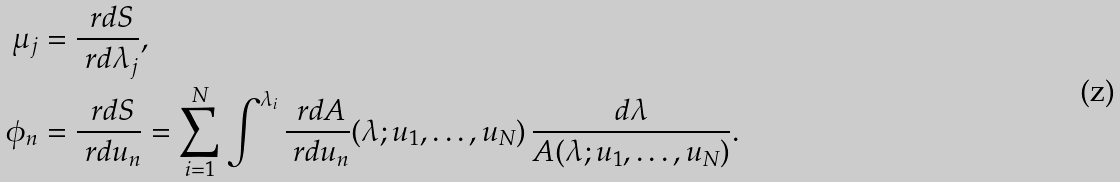Convert formula to latex. <formula><loc_0><loc_0><loc_500><loc_500>\mu _ { j } & = \frac { \ r d S } { \ r d \lambda _ { j } } , \\ \phi _ { n } & = \frac { \ r d S } { \ r d u _ { n } } = \sum _ { i = 1 } ^ { N } \int ^ { \lambda _ { i } } \frac { \ r d A } { \ r d u _ { n } } ( \lambda ; u _ { 1 } , \dots , u _ { N } ) \, \frac { d \lambda } { A ( \lambda ; u _ { 1 } , \dots , u _ { N } ) } .</formula> 